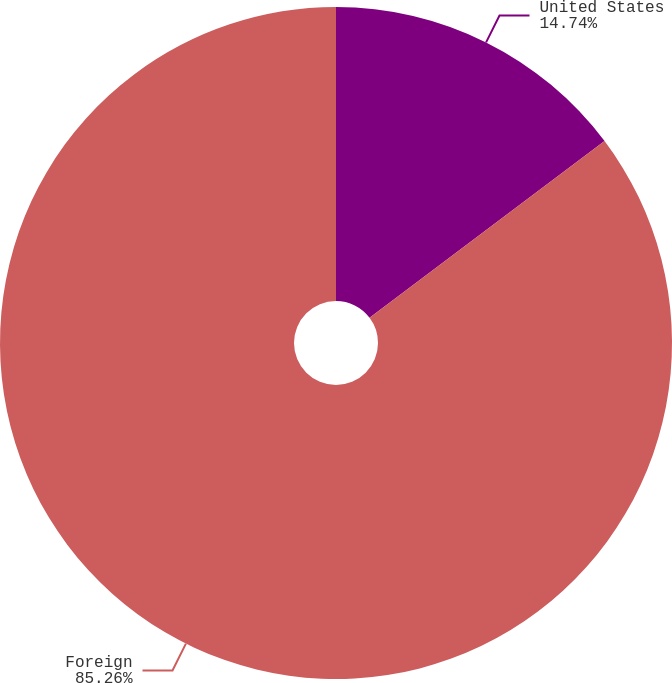Convert chart to OTSL. <chart><loc_0><loc_0><loc_500><loc_500><pie_chart><fcel>United States<fcel>Foreign<nl><fcel>14.74%<fcel>85.26%<nl></chart> 